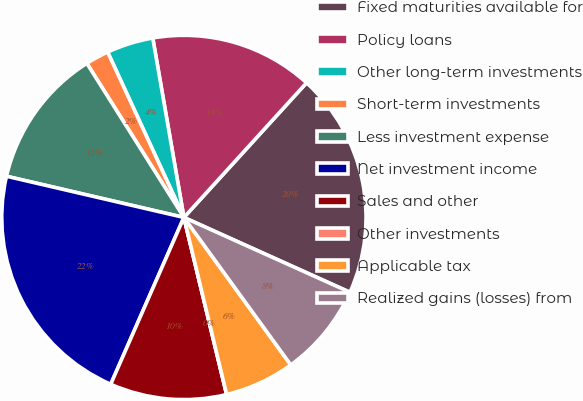<chart> <loc_0><loc_0><loc_500><loc_500><pie_chart><fcel>Fixed maturities available for<fcel>Policy loans<fcel>Other long-term investments<fcel>Short-term investments<fcel>Less investment expense<fcel>Net investment income<fcel>Sales and other<fcel>Other investments<fcel>Applicable tax<fcel>Realized gains (losses) from<nl><fcel>19.98%<fcel>14.49%<fcel>4.14%<fcel>2.07%<fcel>12.42%<fcel>22.05%<fcel>10.35%<fcel>0.0%<fcel>6.21%<fcel>8.28%<nl></chart> 